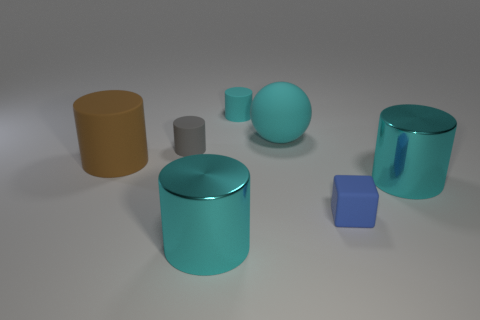Subtract all tiny cylinders. How many cylinders are left? 3 Subtract all cyan cylinders. How many cylinders are left? 2 Add 1 gray cylinders. How many objects exist? 8 Subtract all cylinders. How many objects are left? 2 Subtract 3 cylinders. How many cylinders are left? 2 Subtract all cyan cylinders. Subtract all purple blocks. How many objects are left? 4 Add 6 tiny cyan rubber objects. How many tiny cyan rubber objects are left? 7 Add 3 cyan objects. How many cyan objects exist? 7 Subtract 0 yellow blocks. How many objects are left? 7 Subtract all cyan cylinders. Subtract all purple blocks. How many cylinders are left? 2 